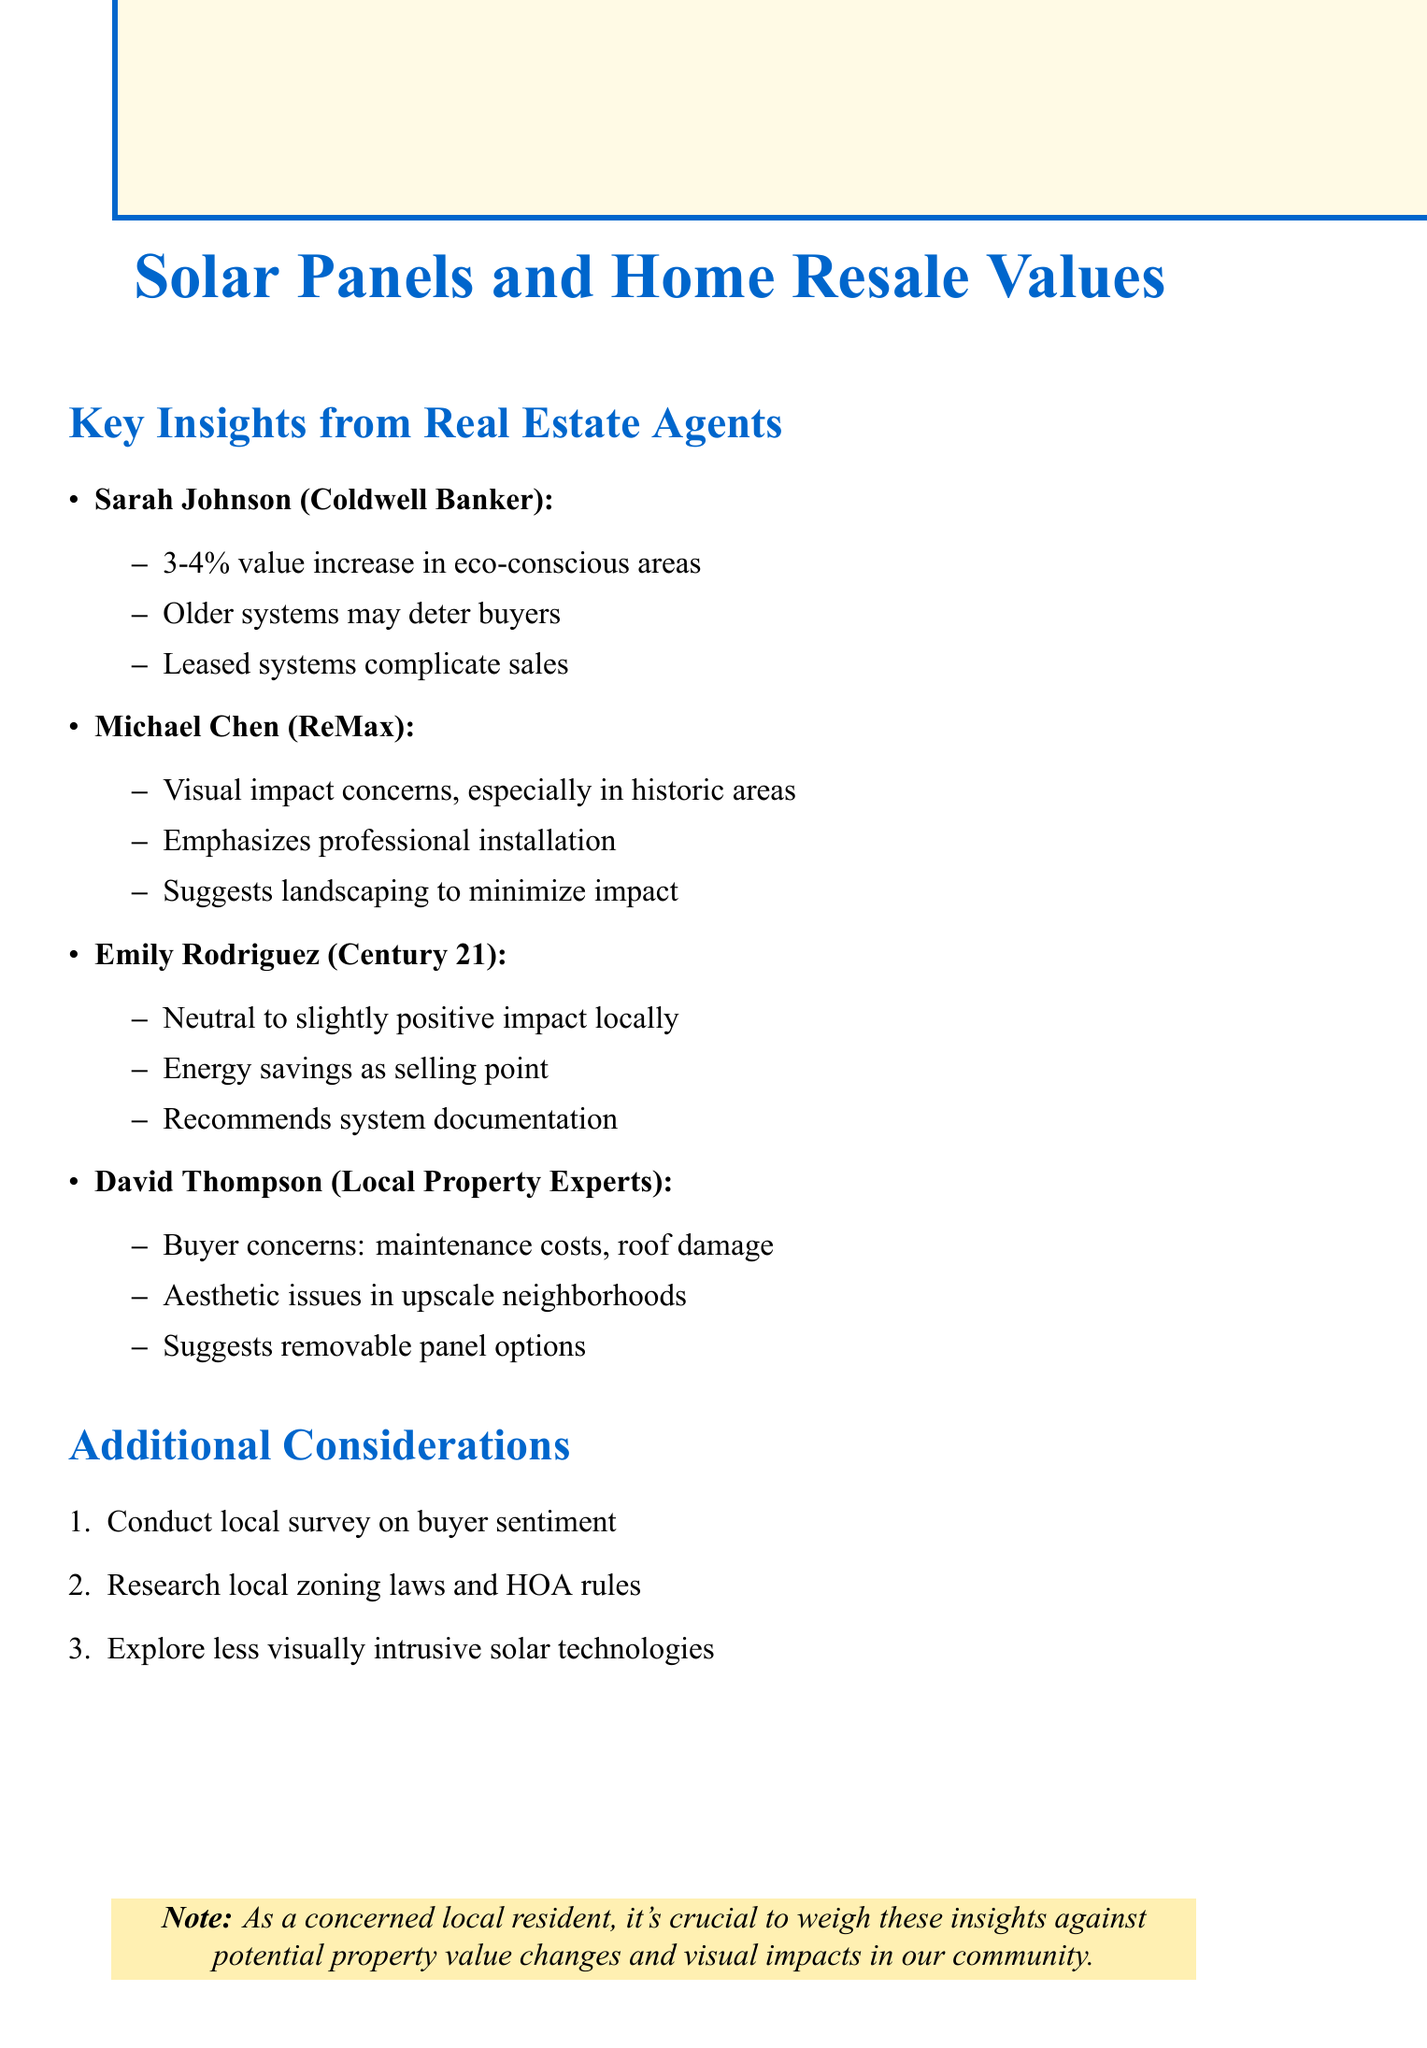what percentage can solar panels increase home value in eco-conscious neighborhoods? This information is stated in the notes from Sarah Johnson, indicating a 3-4% increase.
Answer: 3-4% which real estate agent emphasized landscaping to minimize visual impact? Michael Chen mentioned the importance of landscaping to mitigate visual concerns.
Answer: Michael Chen what is a potential concern for buyers regarding older solar systems? According to Sarah Johnson, older systems may deter some buyers.
Answer: deter buyers what is one suggestion for homeowners hesitant about solar panels? David Thompson suggests removable panel options for those hesitant about installation.
Answer: removable panel options what additional consideration is recommended for understanding buyer sentiment? The notes suggest conducting a local survey to gauge buyer sentiment on solar panels.
Answer: local survey which real estate agent noted that energy cost savings can be an attractive selling point? Emily Rodriguez highlighted energy cost savings as a selling point in her insights.
Answer: Emily Rodriguez what is a concern mentioned regarding the aesthetic impact of solar panels? David Thompson noted aesthetic concerns are more prominent in upscale neighborhoods.
Answer: aesthetic concerns what documentation is recommended for home systems? Emily Rodriguez recommends having documentation of system performance and maintenance.
Answer: documentation of system performance and maintenance 